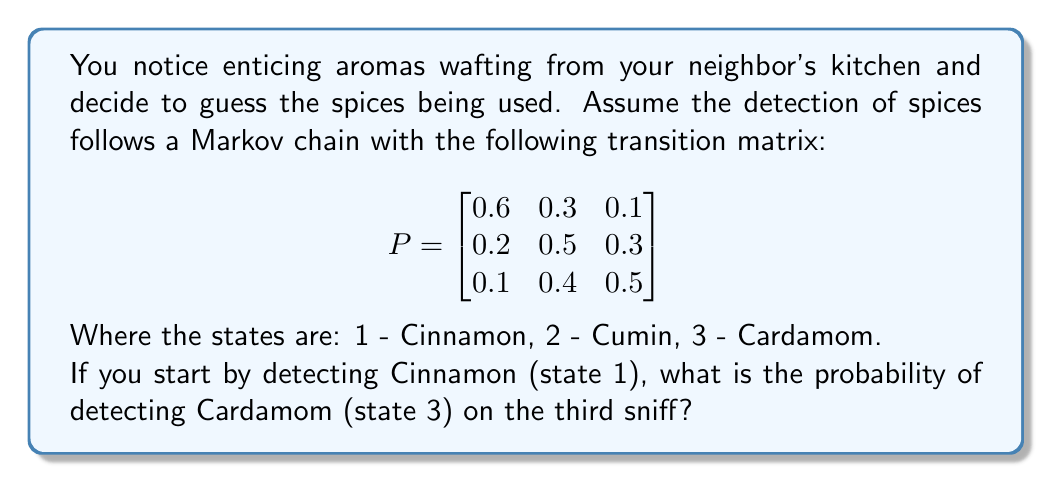Can you solve this math problem? To solve this problem, we need to use the Chapman-Kolmogorov equations and calculate the 3-step transition probability from state 1 to state 3.

Step 1: Calculate $P^3$ (the transition matrix raised to the power of 3).
$$P^3 = P \times P \times P$$

We can use matrix multiplication or a calculator to compute this. The result is:

$$
P^3 = \begin{bmatrix}
0.308 & 0.406 & 0.286 \\
0.238 & 0.442 & 0.320 \\
0.227 & 0.437 & 0.336
\end{bmatrix}
$$

Step 2: Identify the required probability.
The probability of moving from state 1 to state 3 in 3 steps is given by the element in the first row, third column of $P^3$.

Therefore, the probability of detecting Cardamom on the third sniff, given that you start by detecting Cinnamon, is 0.286 or 28.6%.
Answer: 0.286 